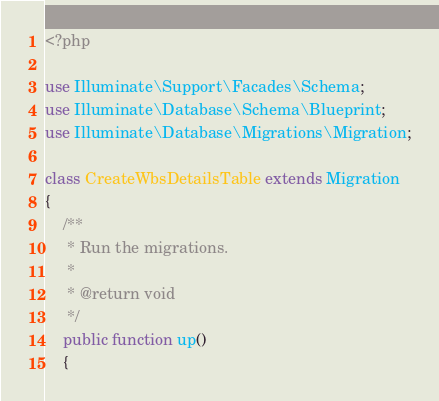Convert code to text. <code><loc_0><loc_0><loc_500><loc_500><_PHP_><?php

use Illuminate\Support\Facades\Schema;
use Illuminate\Database\Schema\Blueprint;
use Illuminate\Database\Migrations\Migration;

class CreateWbsDetailsTable extends Migration
{
    /**
     * Run the migrations.
     *
     * @return void
     */
    public function up()
    {</code> 